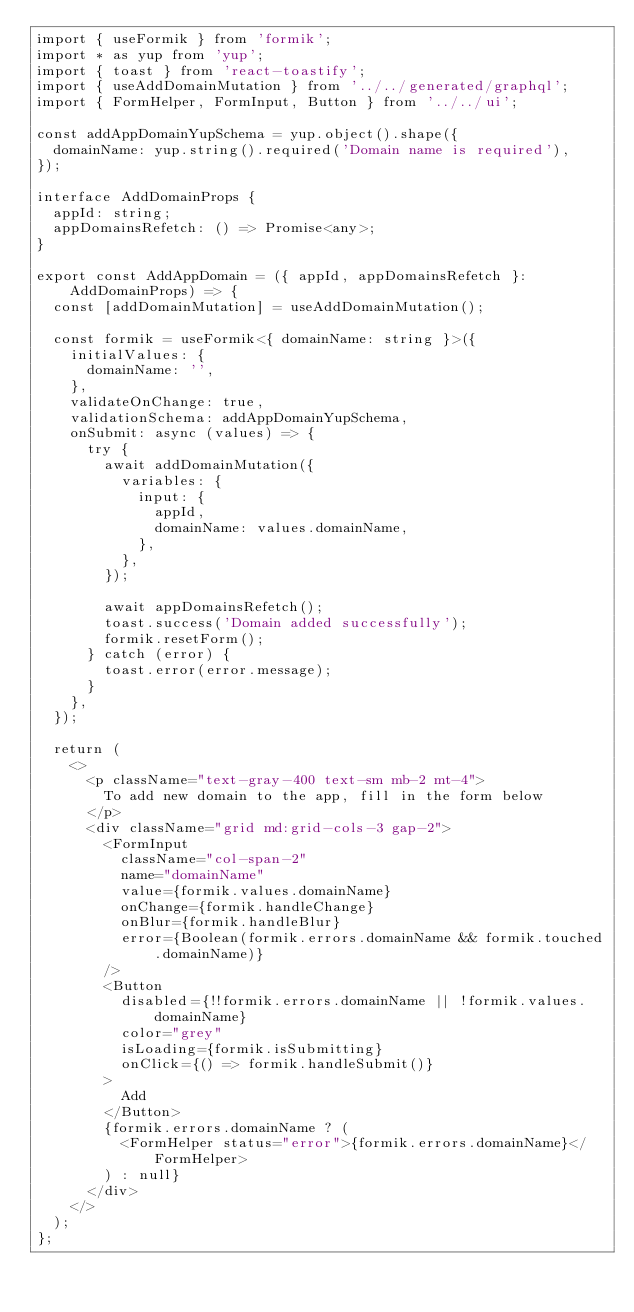Convert code to text. <code><loc_0><loc_0><loc_500><loc_500><_TypeScript_>import { useFormik } from 'formik';
import * as yup from 'yup';
import { toast } from 'react-toastify';
import { useAddDomainMutation } from '../../generated/graphql';
import { FormHelper, FormInput, Button } from '../../ui';

const addAppDomainYupSchema = yup.object().shape({
  domainName: yup.string().required('Domain name is required'),
});

interface AddDomainProps {
  appId: string;
  appDomainsRefetch: () => Promise<any>;
}

export const AddAppDomain = ({ appId, appDomainsRefetch }: AddDomainProps) => {
  const [addDomainMutation] = useAddDomainMutation();

  const formik = useFormik<{ domainName: string }>({
    initialValues: {
      domainName: '',
    },
    validateOnChange: true,
    validationSchema: addAppDomainYupSchema,
    onSubmit: async (values) => {
      try {
        await addDomainMutation({
          variables: {
            input: {
              appId,
              domainName: values.domainName,
            },
          },
        });

        await appDomainsRefetch();
        toast.success('Domain added successfully');
        formik.resetForm();
      } catch (error) {
        toast.error(error.message);
      }
    },
  });

  return (
    <>
      <p className="text-gray-400 text-sm mb-2 mt-4">
        To add new domain to the app, fill in the form below
      </p>
      <div className="grid md:grid-cols-3 gap-2">
        <FormInput
          className="col-span-2"
          name="domainName"
          value={formik.values.domainName}
          onChange={formik.handleChange}
          onBlur={formik.handleBlur}
          error={Boolean(formik.errors.domainName && formik.touched.domainName)}
        />
        <Button
          disabled={!!formik.errors.domainName || !formik.values.domainName}
          color="grey"
          isLoading={formik.isSubmitting}
          onClick={() => formik.handleSubmit()}
        >
          Add
        </Button>
        {formik.errors.domainName ? (
          <FormHelper status="error">{formik.errors.domainName}</FormHelper>
        ) : null}
      </div>
    </>
  );
};
</code> 